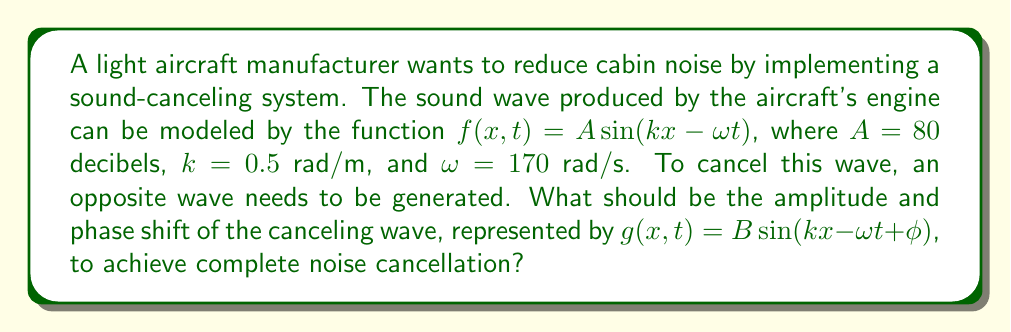What is the answer to this math problem? To achieve complete noise cancellation, we need to generate a wave that is exactly opposite to the original wave. This means:

1. The amplitude of the canceling wave should be equal to the original wave but in the opposite direction:
   $B = -A = -80$ decibels

2. The phase shift $\phi$ should make the sine function in $g(x,t)$ opposite to the sine function in $f(x,t)$. This is achieved when the arguments of the sine functions differ by $\pi$ radians:

   $kx - \omega t + \phi = kx - \omega t + \pi$

   Therefore, $\phi = \pi$ radians

3. The resulting canceling wave function will be:

   $g(x,t) = -80 \sin(0.5x - 170t + \pi)$

4. We can verify that $f(x,t) + g(x,t) = 0$ for all $x$ and $t$:

   $80 \sin(0.5x - 170t) + (-80) \sin(0.5x - 170t + \pi)$
   $= 80 \sin(0.5x - 170t) - 80 \sin(0.5x - 170t)$
   $= 0$

Thus, complete noise cancellation is achieved.
Answer: $B = -80$ dB, $\phi = \pi$ rad 